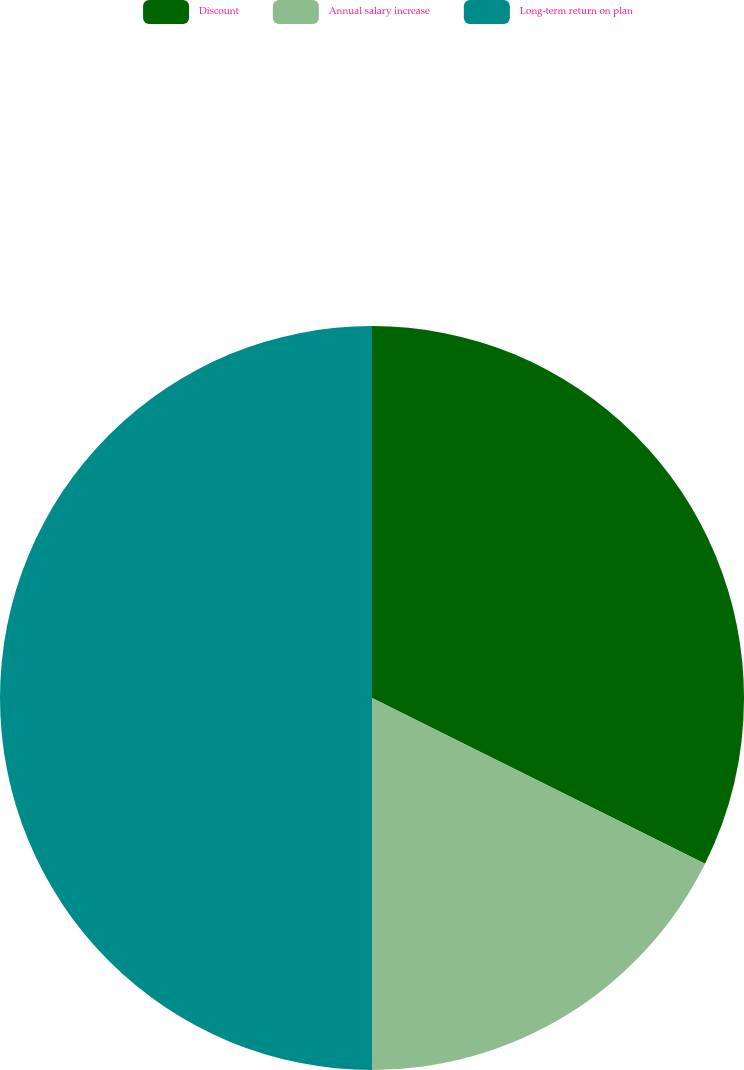Convert chart. <chart><loc_0><loc_0><loc_500><loc_500><pie_chart><fcel>Discount<fcel>Annual salary increase<fcel>Long-term return on plan<nl><fcel>32.35%<fcel>17.65%<fcel>50.0%<nl></chart> 